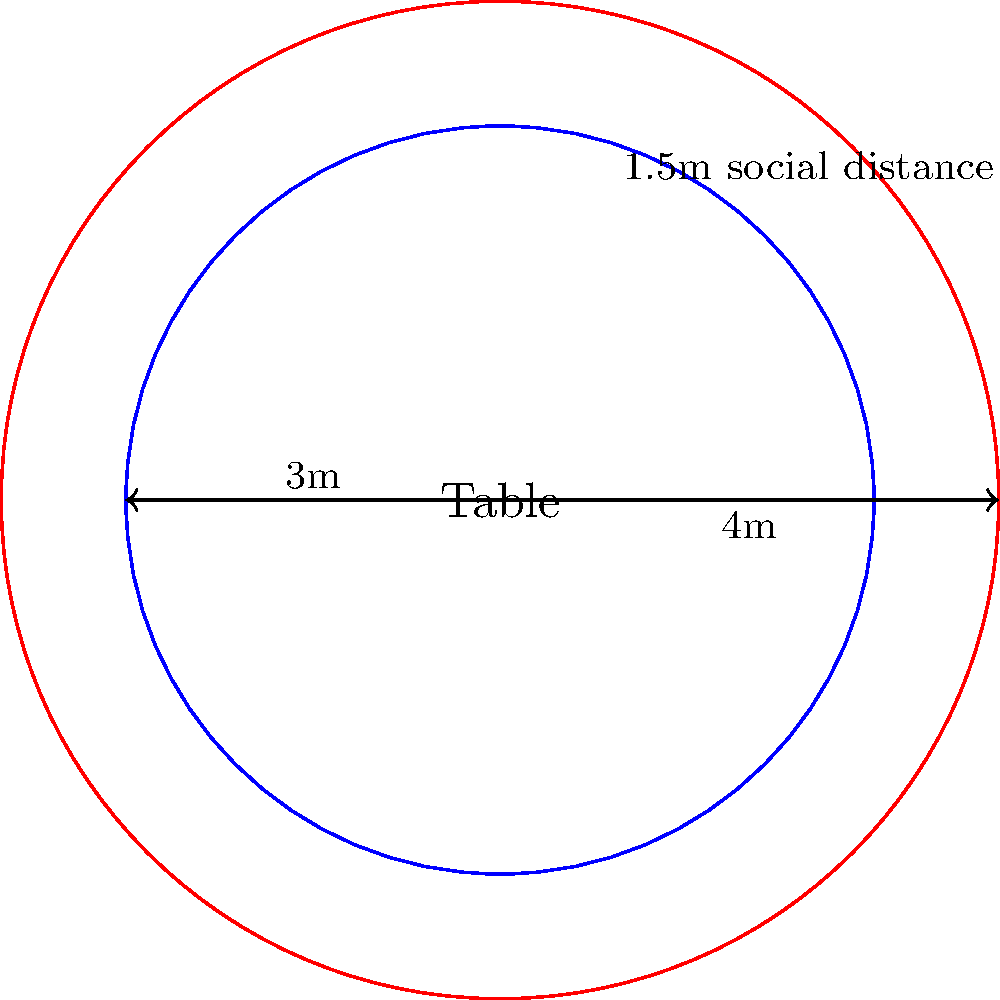To maintain social distancing in your eco-friendly restaurant, you need to ensure a 1.5m gap between circular tables. If the maximum allowed table radius is 3m and the minimum required distance between table centers is 4m, what is the maximum number of customers that can be seated around one table if each customer requires 0.6m of table circumference? Let's approach this step-by-step:

1) First, we need to calculate the circumference of the table:
   Circumference = $2\pi r$ = $2\pi \cdot 3$ = $6\pi$ meters

2) Now, we need to determine how much of this circumference each customer occupies:
   Space per customer = 0.6m

3) To find the number of customers, we divide the total circumference by the space per customer:
   Number of customers = $\frac{\text{Circumference}}{\text{Space per customer}}$ = $\frac{6\pi}{0.6}$ = $10\pi$

4) Since we can't seat a fractional number of customers, we need to round down to the nearest whole number:
   Maximum number of customers = floor($10\pi$) = floor(31.4159...) = 31

Therefore, the maximum number of customers that can be seated around one table while maintaining the required personal space is 31.
Answer: 31 customers 